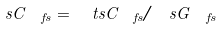<formula> <loc_0><loc_0><loc_500><loc_500>\ s C _ { \ f s } = \ t s C _ { \ f s } / \ s G _ { \ f s }</formula> 